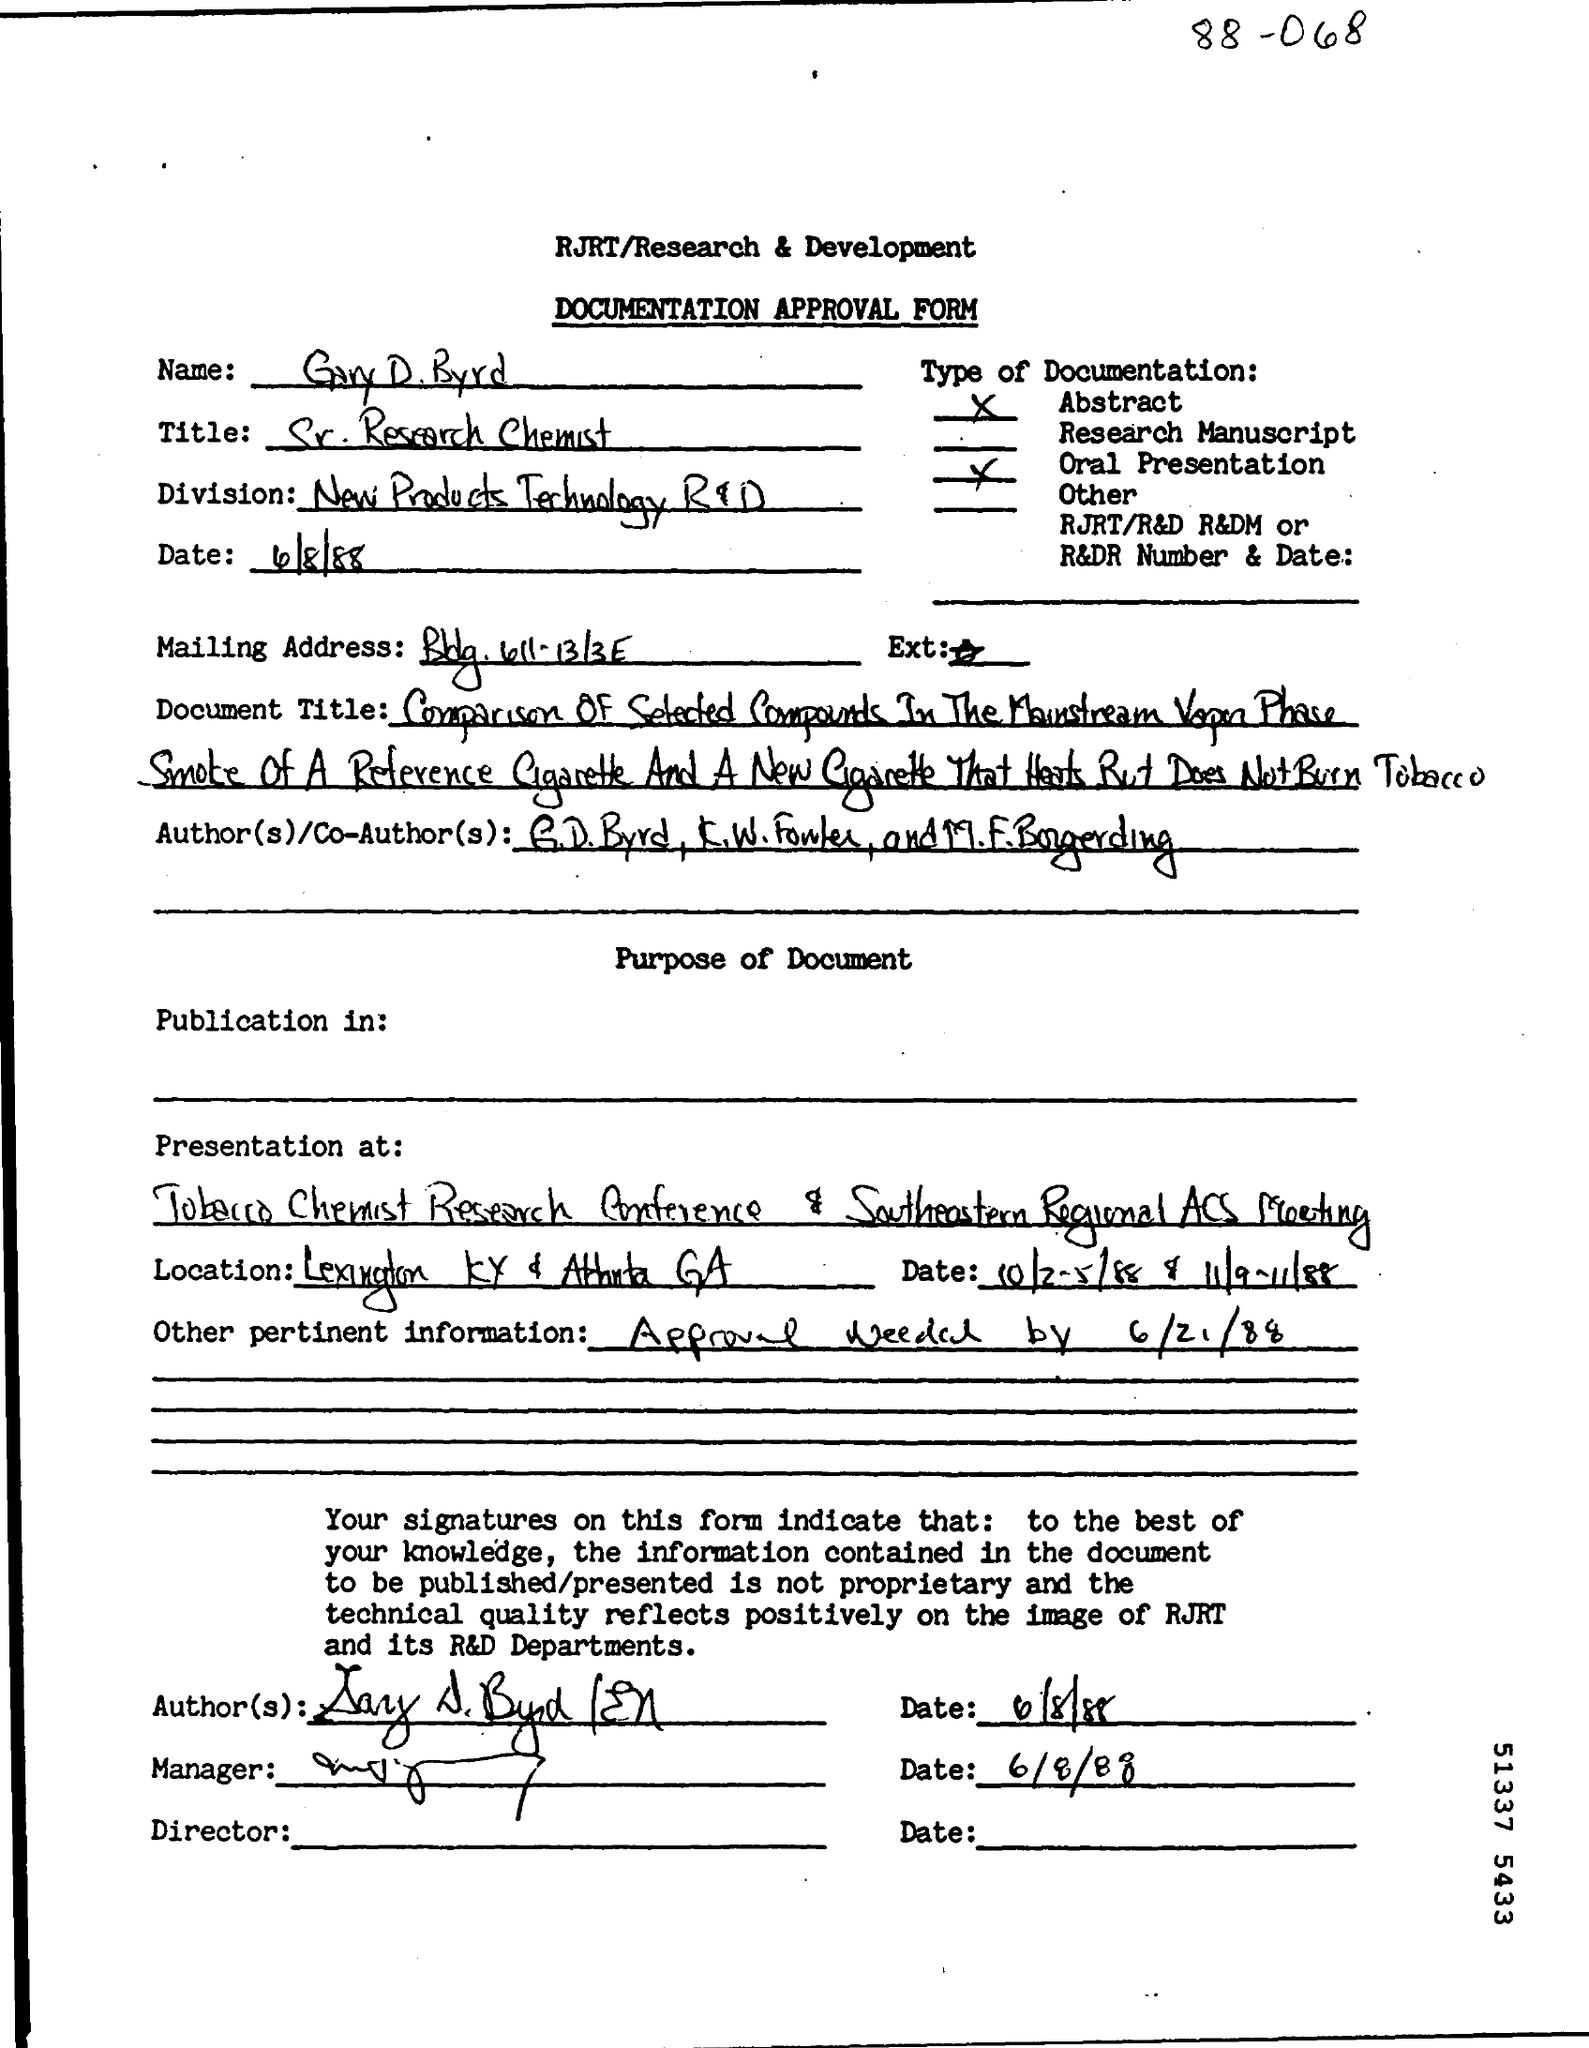What is the name of the division given in the approval form ?
Your answer should be very brief. New Products Technology R&D. What is the date mentioned in the approval form ?
Your response must be concise. 4/8/88. 